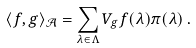Convert formula to latex. <formula><loc_0><loc_0><loc_500><loc_500>\langle f , g \rangle _ { \mathcal { A } } = \sum _ { \lambda \in \Lambda } V _ { g } f ( \lambda ) \pi ( \lambda ) \, .</formula> 